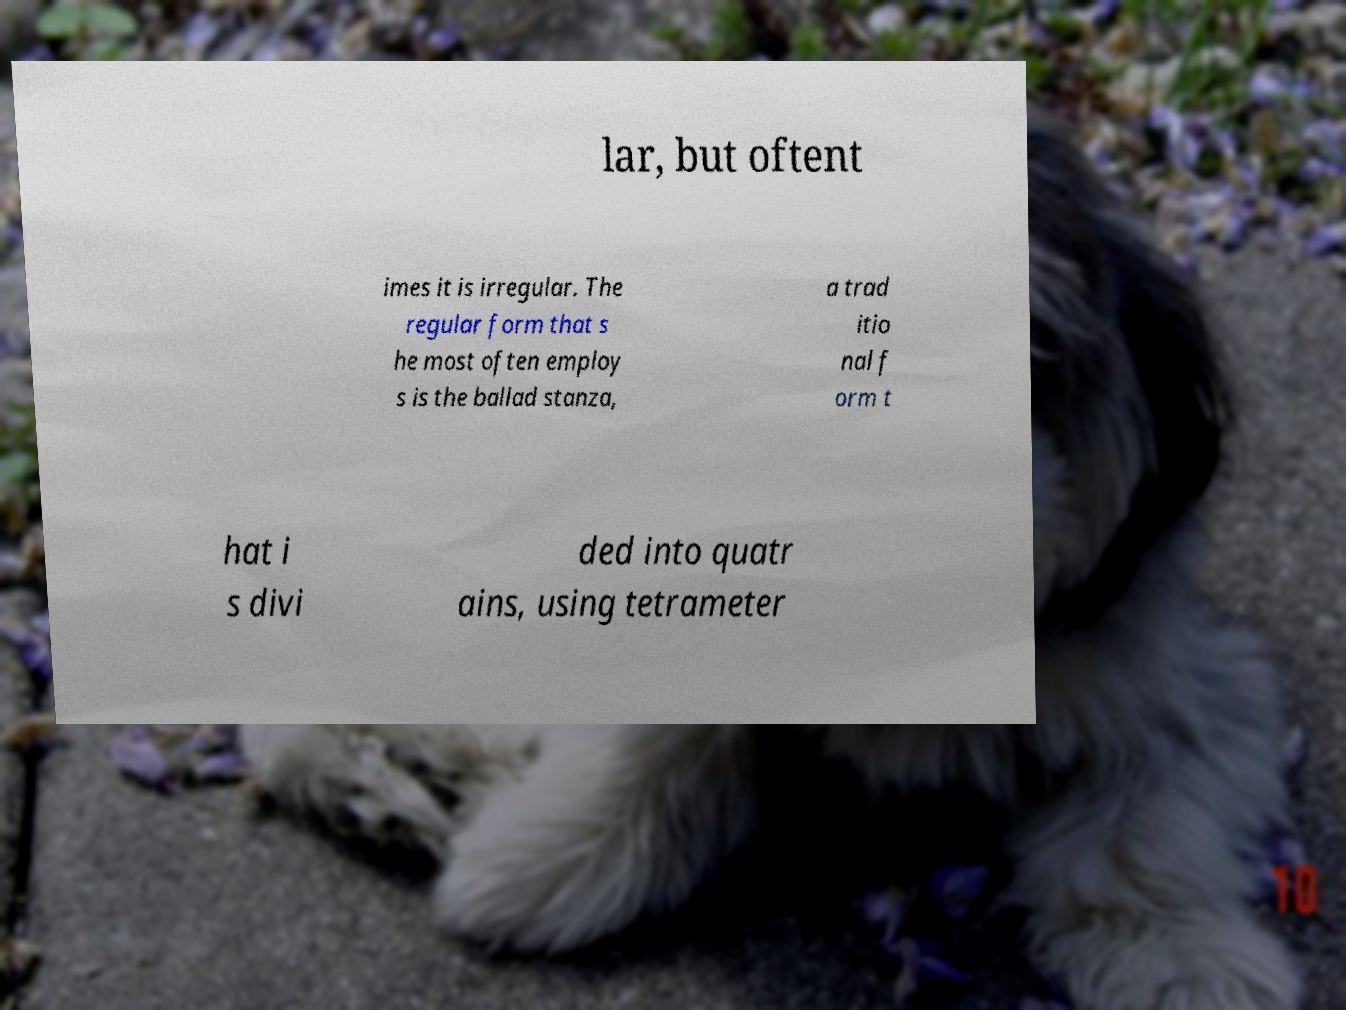For documentation purposes, I need the text within this image transcribed. Could you provide that? lar, but oftent imes it is irregular. The regular form that s he most often employ s is the ballad stanza, a trad itio nal f orm t hat i s divi ded into quatr ains, using tetrameter 